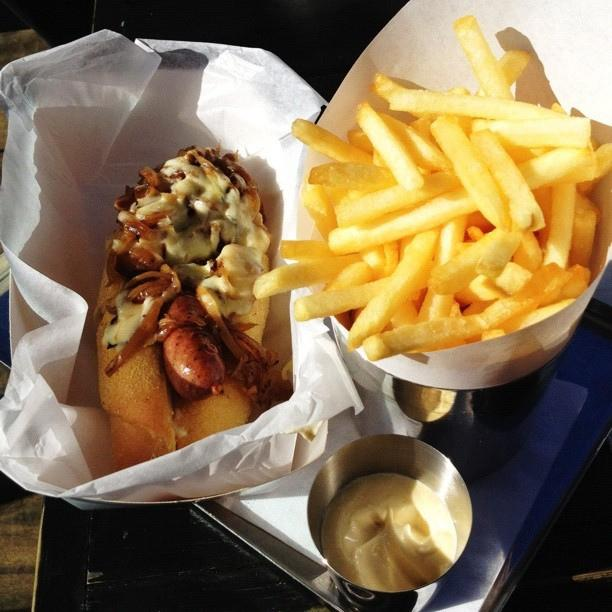What place sells these items? restaurant 